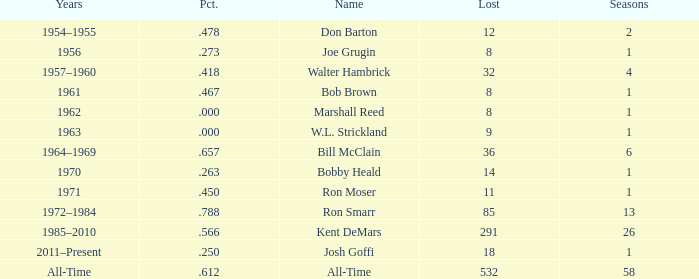Which Seasons has a Name of joe grugin, and a Lost larger than 8? 0.0. 